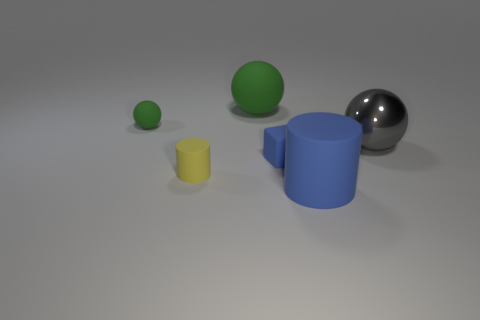Add 1 big purple metal cubes. How many objects exist? 7 Subtract all cylinders. How many objects are left? 4 Add 2 gray spheres. How many gray spheres exist? 3 Subtract 0 purple cylinders. How many objects are left? 6 Subtract all small rubber cylinders. Subtract all metal spheres. How many objects are left? 4 Add 4 tiny blue rubber things. How many tiny blue rubber things are left? 5 